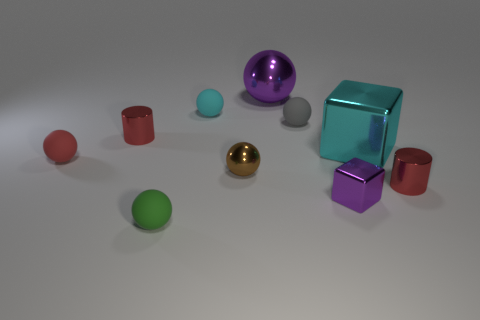Subtract all purple balls. How many balls are left? 5 Subtract all green spheres. How many spheres are left? 5 Subtract 4 balls. How many balls are left? 2 Subtract all brown spheres. Subtract all brown blocks. How many spheres are left? 5 Subtract all cylinders. How many objects are left? 8 Subtract 0 red cubes. How many objects are left? 10 Subtract all small objects. Subtract all purple objects. How many objects are left? 0 Add 7 cyan things. How many cyan things are left? 9 Add 8 tiny cylinders. How many tiny cylinders exist? 10 